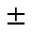Convert formula to latex. <formula><loc_0><loc_0><loc_500><loc_500>\pm</formula> 